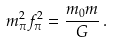<formula> <loc_0><loc_0><loc_500><loc_500>m _ { \pi } ^ { 2 } f _ { \pi } ^ { 2 } = \frac { m _ { 0 } m } { G } \, .</formula> 